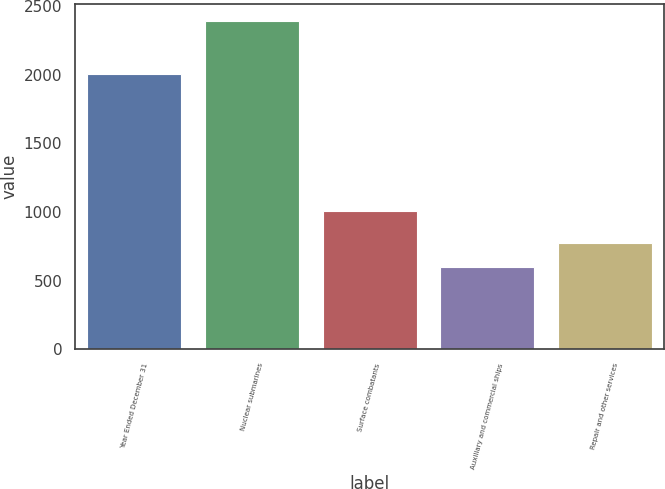<chart> <loc_0><loc_0><loc_500><loc_500><bar_chart><fcel>Year Ended December 31<fcel>Nuclear submarines<fcel>Surface combatants<fcel>Auxiliary and commercial ships<fcel>Repair and other services<nl><fcel>2005<fcel>2396<fcel>1008<fcel>598<fcel>777.8<nl></chart> 